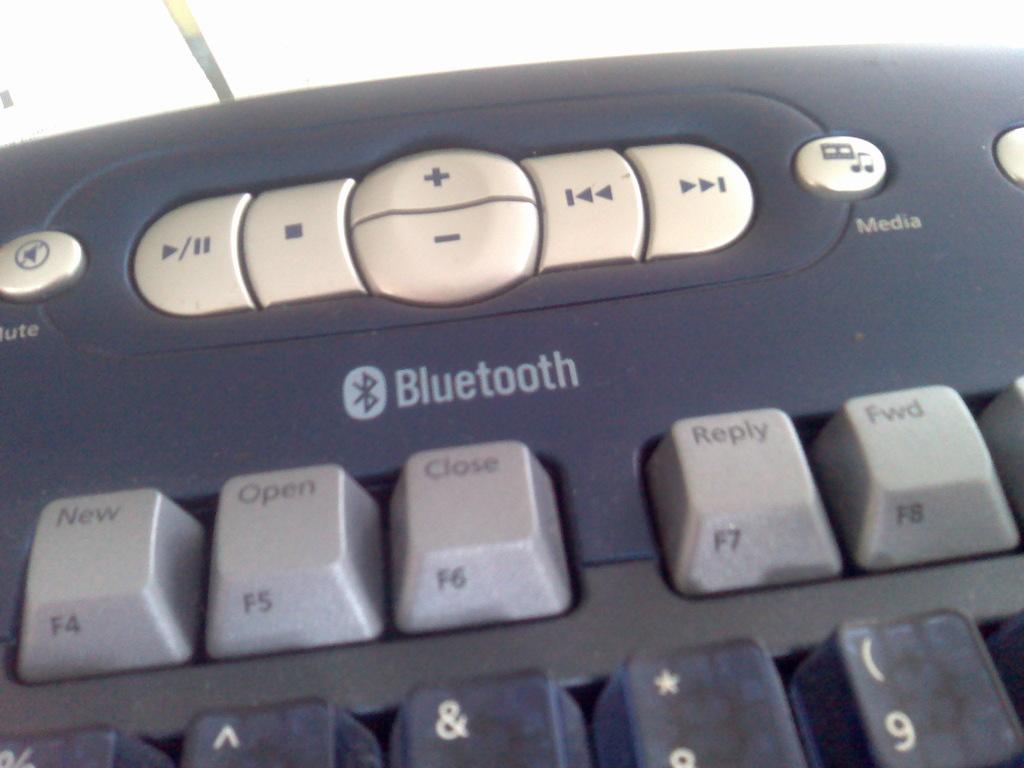What can the keyboard connect to?
Provide a succinct answer. Bluetooth. What "f key" number is on the "close" button?
Offer a very short reply. F6. 